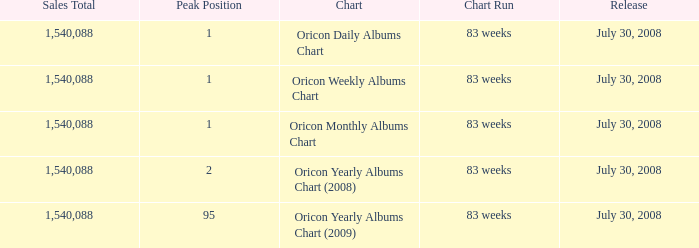Which Sales Total has a Chart of oricon monthly albums chart? 1540088.0. 